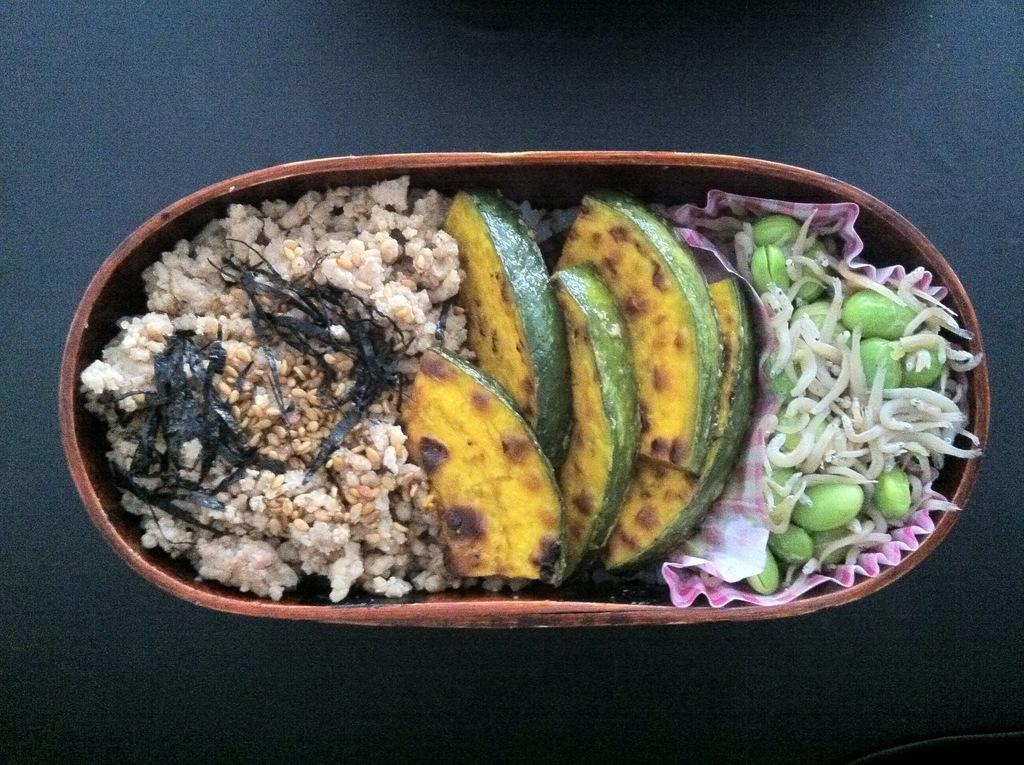What type of objects are present in the image? There are food items in the image. How are the food items stored or contained? The food items are kept in a container. Where is the container located in the image? The container is in the middle of the image. On what surface is the container placed? The container is placed on a surface. What can be seen in the background of the image? The surface on which the container is placed can be seen in the background of the image. What type of harmony can be heard in the background of the image? There is no audible harmony present in the image, as it is a still image of food items in a container. 